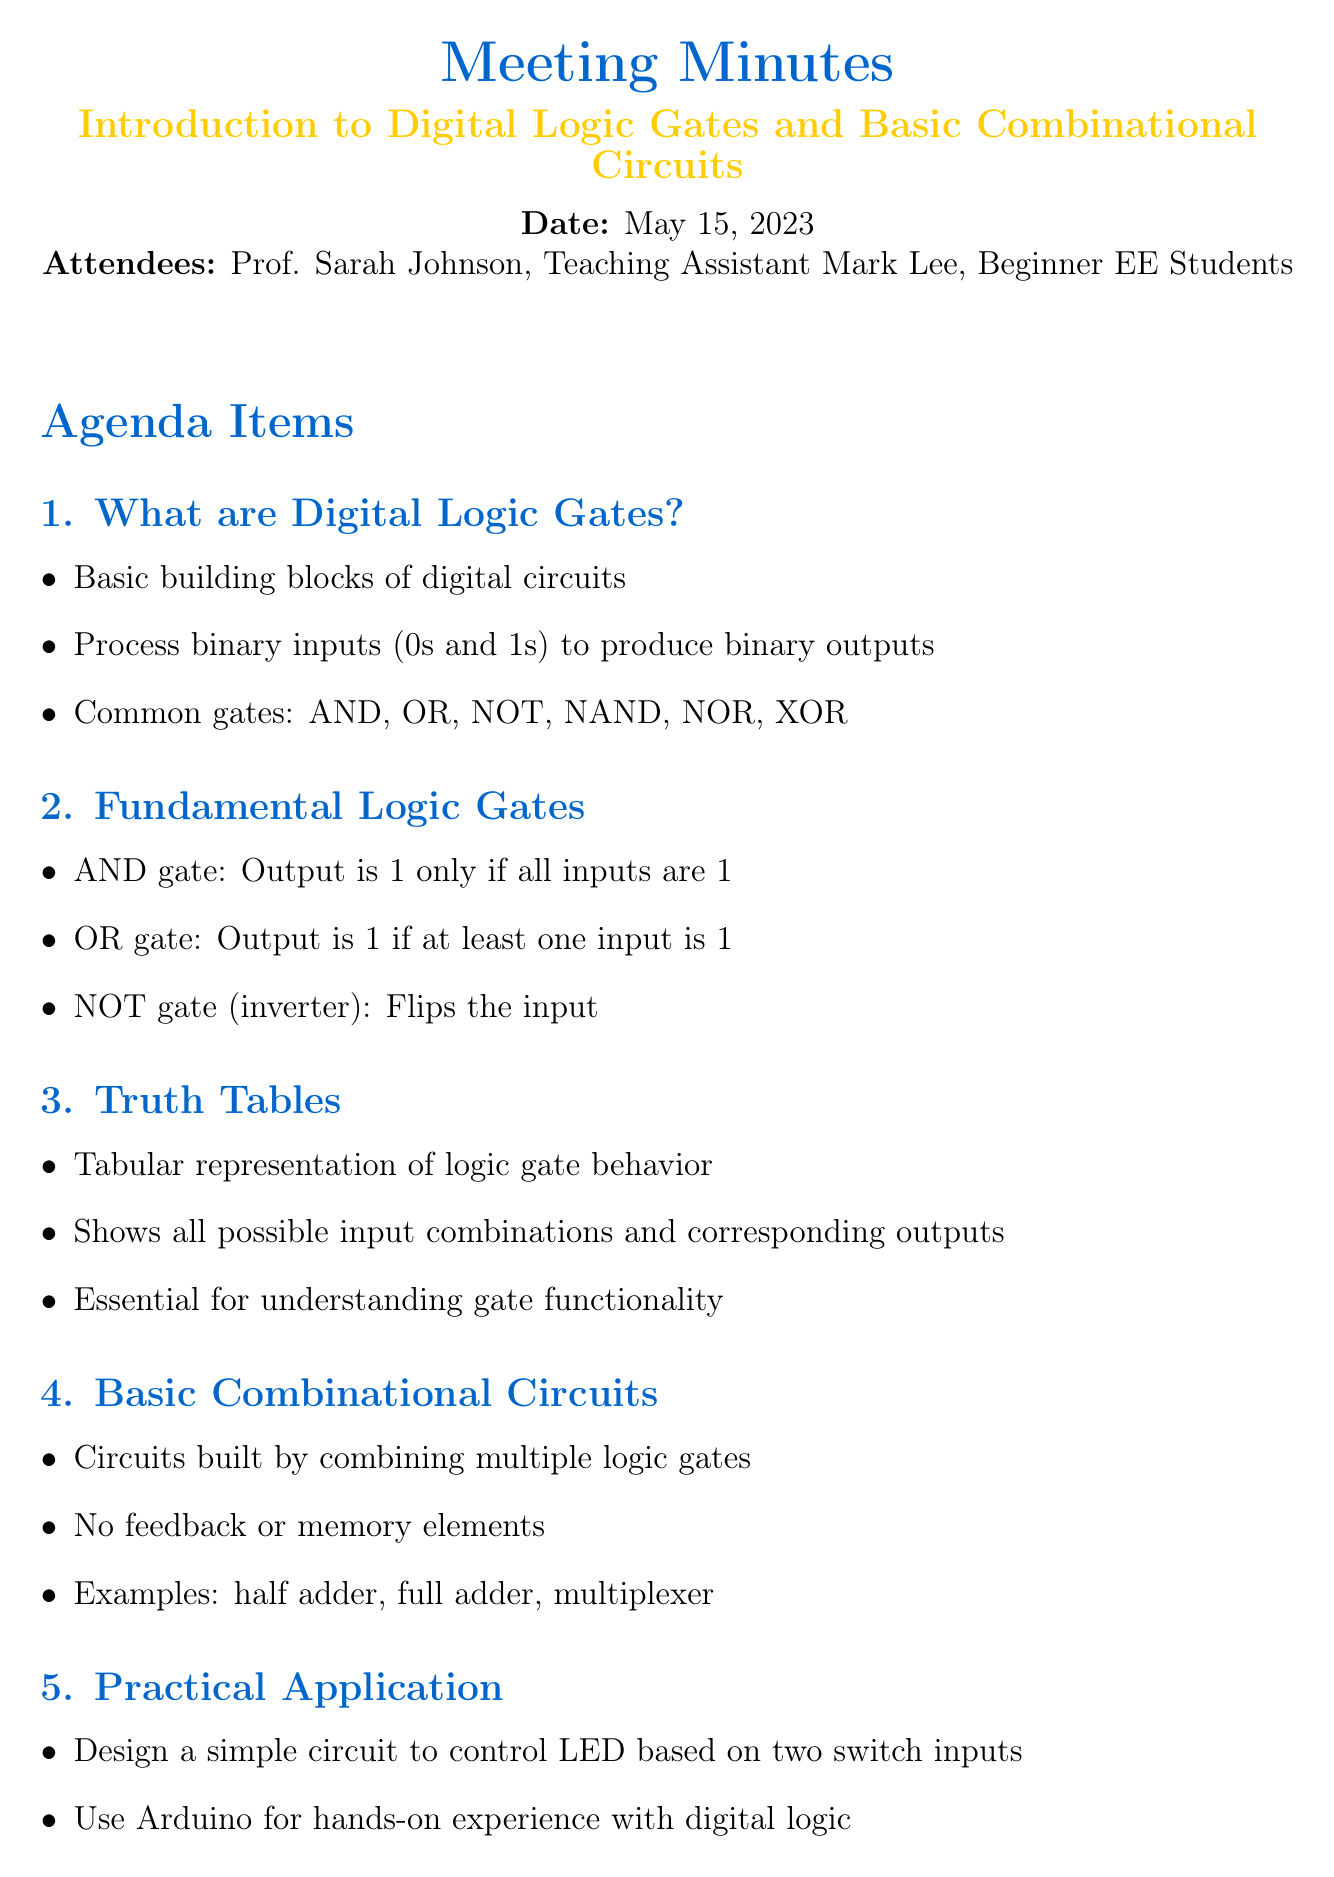What is the meeting title? The meeting title is explicitly stated at the beginning of the document.
Answer: Introduction to Digital Logic Gates and Basic Combinational Circuits Who were the attendees? The attendees are listed in a section of the document under "Attendees."
Answer: Prof. Sarah Johnson, Teaching Assistant Mark Lee, Beginner EE Students What is an AND gate? The definition of an AND gate is provided in the section on Fundamental Logic Gates.
Answer: Output is 1 only if all inputs are 1 Which logic gate flips the input? The document provides specific functionalities of fundamental logic gates, including the NOT gate.
Answer: NOT gate What does a truth table represent? The document explains the purpose of a truth table in the context of logic gates.
Answer: Tabular representation of logic gate behavior What is an example of a basic combinational circuit? An example is given in the section on Basic Combinational Circuits.
Answer: Half adder What is a suggested next step for beginners? The Next Steps section lists several activities for beginners to improve their understanding.
Answer: Practice creating truth tables for different gates What is the date of the meeting? The date is stated clearly at the top of the meeting minutes.
Answer: May 15, 2023 What practical application was discussed in the meeting? The meeting minutes describe a specific hands-on project associated with digital logic.
Answer: Design a simple circuit to control LED based on two switch inputs What is common to all logic gates? The initial section outlines the function of digital logic gates collectively.
Answer: Process binary inputs (0s and 1s) to produce binary outputs 